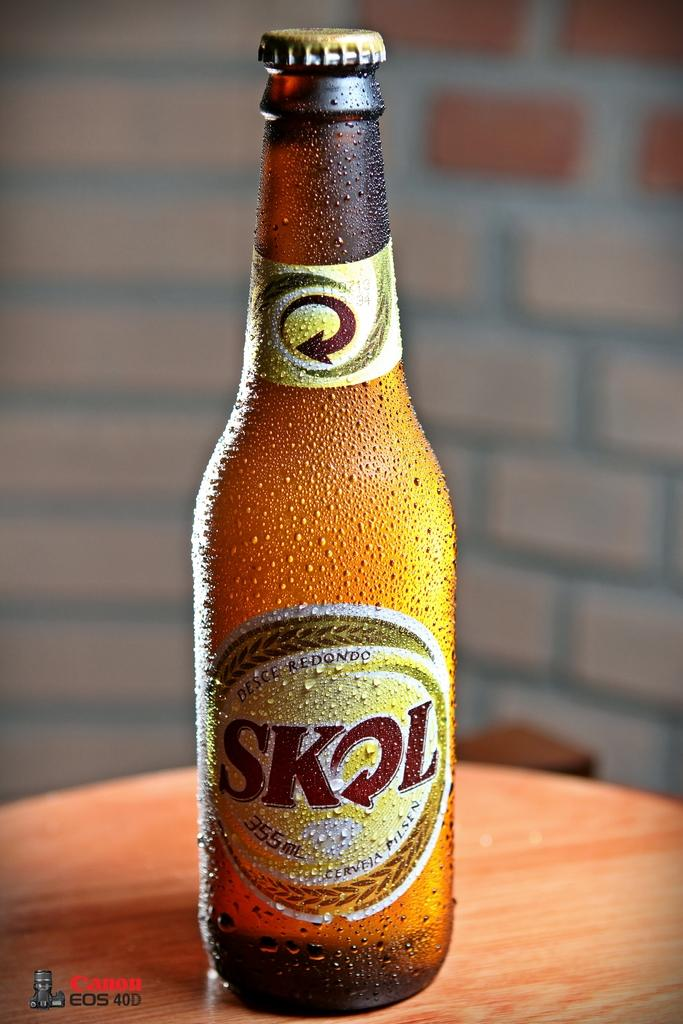<image>
Create a compact narrative representing the image presented. A bottle of Skol beer sits on small round table. 